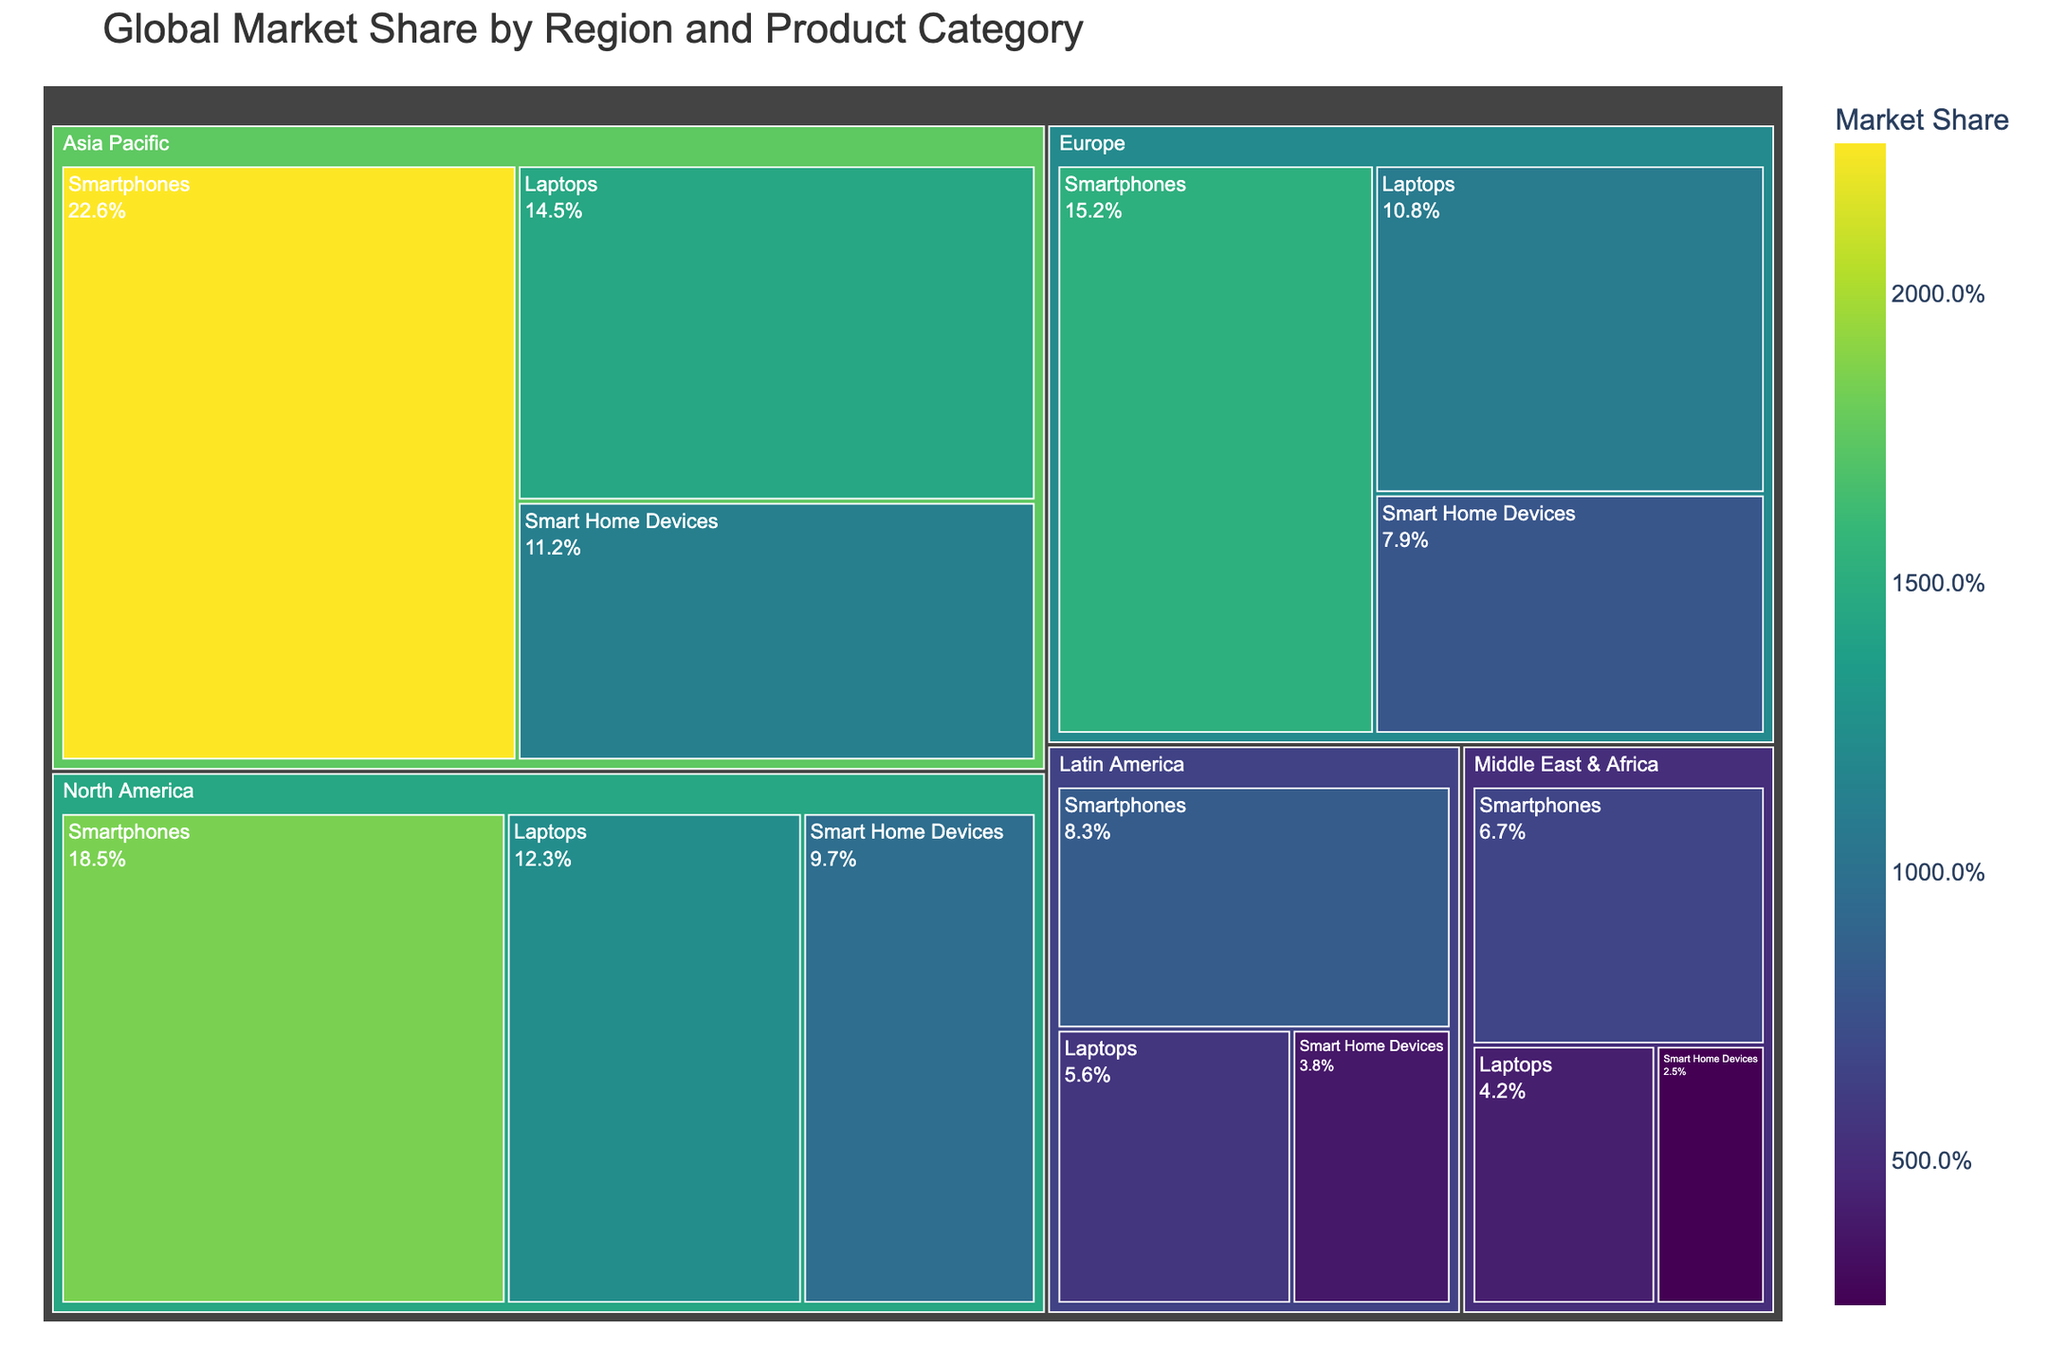What is the title of the treemap? The title is located at the top of the treemap and provides an overview of the visualized data. It helps viewers quickly understand what the figure represents.
Answer: Global Market Share by Region and Product Category Which region has the highest market share for Smartphones? You can see the relative sizes of the segments and their labels indicating market shares. The largest segment under Smartphones belongs to Asia Pacific.
Answer: Asia Pacific What's the combined market share of Laptops in North America and Europe? Combine the market shares for Laptops in both regions by adding 12.3 (North America) and 10.8 (Europe).
Answer: 23.1% Which product category has the smallest market share in Latin America? Each product category's market share in Latin America is labeled in the treemap. Identify the smallest percentage.
Answer: Smart Home Devices Which region has the smallest market share for Smart Home Devices? Compare the segments under Smart Home Devices category for different regions. The smallest segment belongs to Middle East & Africa.
Answer: Middle East & Africa How does the market share of Smartphones in Europe compare to that in North America? Check the respective market shares for Smartphones in the regions mentioned and compare them. Europe has 15.2% and North America has 18.5%.
Answer: North America has a higher market share What is the market share difference between Smart Home Devices in Asia Pacific and Europe? Subtract the market share of Smart Home Devices in Europe (7.9%) from that in Asia Pacific (11.2%).
Answer: 3.3% Which region has the most balanced market share distribution among the three product categories? Look at the relative sizes of three categories within each region. The region with similar-sized segments for categories is considered balanced.
Answer: Europe What is the average market share for Smartphones across all regions? Add the market shares of Smartphones from all regions then divide by the number of regions (5): (18.5 + 15.2 + 22.6 + 8.3 + 6.7) / 5.
Answer: 14.26% In which region do Laptops have nearly equal market shares to Smart Home Devices? Compare the market shares of Laptops and Smart Home Devices in each region. The values are the closest in North America, where the market shares are 12.3% and 9.7% respectively.
Answer: North America 